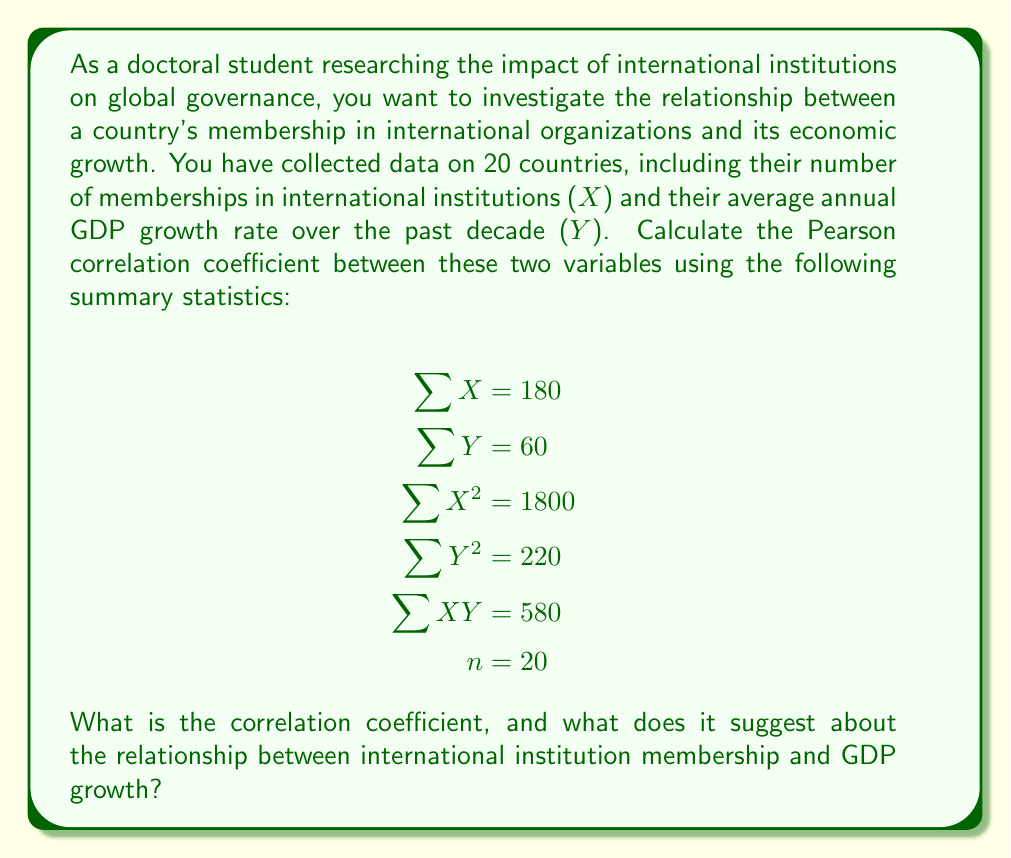Can you solve this math problem? To calculate the Pearson correlation coefficient (r), we'll use the formula:

$$r = \frac{n\sum XY - \sum X \sum Y}{\sqrt{[n\sum X^2 - (\sum X)^2][n\sum Y^2 - (\sum Y)^2]}}$$

Let's substitute the given values and solve step by step:

1. Calculate $n\sum XY$:
   $20 \times 580 = 11600$

2. Calculate $\sum X \sum Y$:
   $180 \times 60 = 10800$

3. Calculate the numerator:
   $11600 - 10800 = 800$

4. Calculate $n\sum X^2$:
   $20 \times 1800 = 36000$

5. Calculate $(\sum X)^2$:
   $180^2 = 32400$

6. Calculate $n\sum Y^2$:
   $20 \times 220 = 4400$

7. Calculate $(\sum Y)^2$:
   $60^2 = 3600$

8. Calculate the denominator:
   $\sqrt{[36000 - 32400][4400 - 3600]} = \sqrt{3600 \times 800} = \sqrt{2880000} = 1697.06$

9. Finally, calculate r:
   $r = \frac{800}{1697.06} \approx 0.4714$

The correlation coefficient is approximately 0.4714, which indicates a moderate positive correlation between international institution membership and GDP growth. This suggests that countries with more memberships in international institutions tend to have slightly higher GDP growth rates, but the relationship is not extremely strong.
Answer: $r \approx 0.4714$, indicating a moderate positive correlation between international institution membership and GDP growth. 